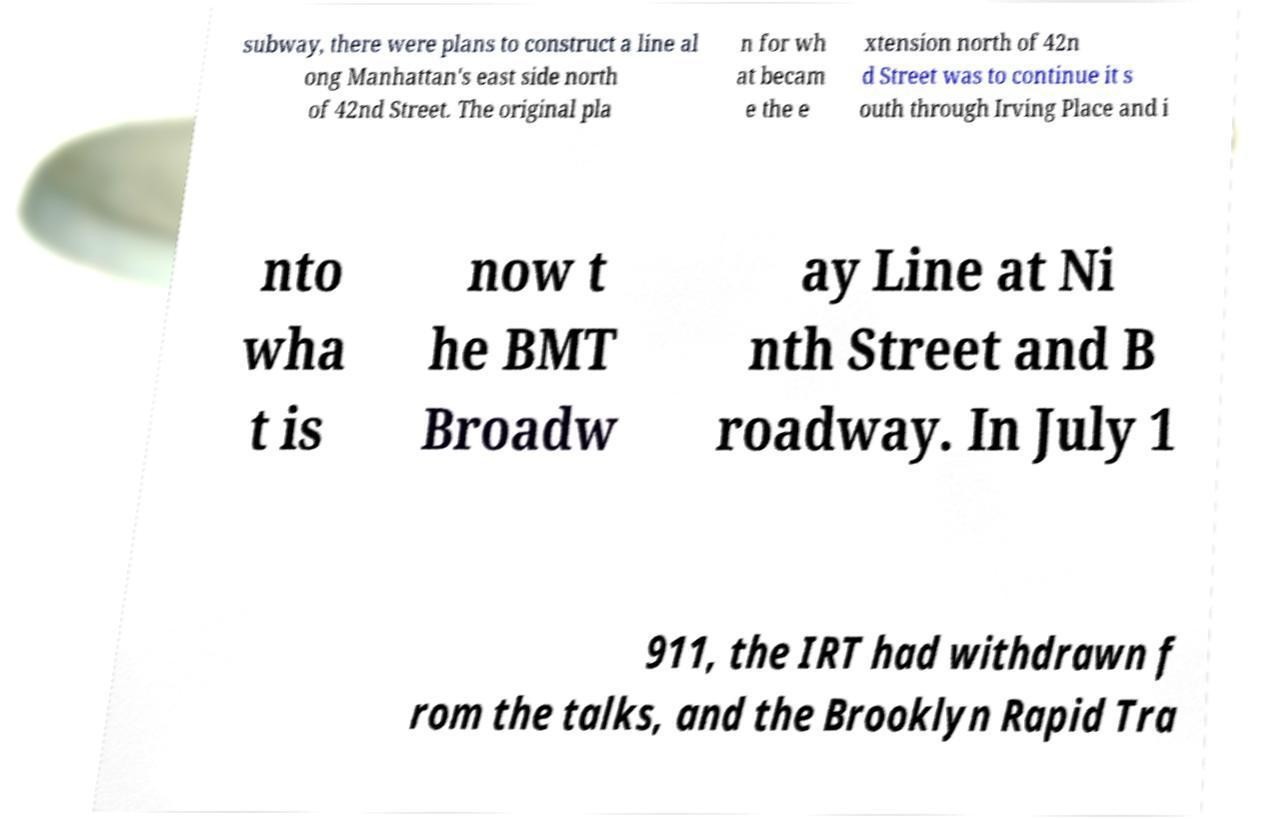Can you accurately transcribe the text from the provided image for me? subway, there were plans to construct a line al ong Manhattan's east side north of 42nd Street. The original pla n for wh at becam e the e xtension north of 42n d Street was to continue it s outh through Irving Place and i nto wha t is now t he BMT Broadw ay Line at Ni nth Street and B roadway. In July 1 911, the IRT had withdrawn f rom the talks, and the Brooklyn Rapid Tra 